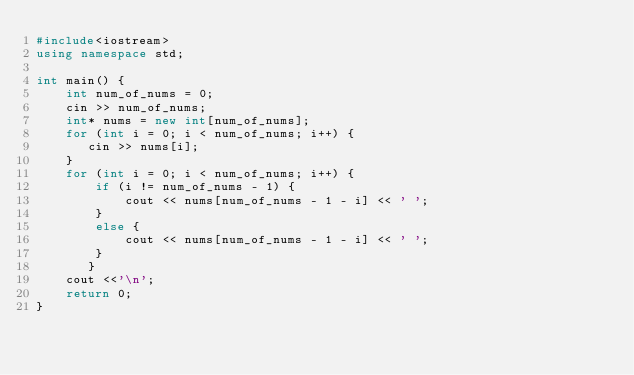Convert code to text. <code><loc_0><loc_0><loc_500><loc_500><_C++_>#include<iostream>
using namespace std;

int main() {
	int num_of_nums = 0;
	cin >> num_of_nums;
    int* nums = new int[num_of_nums];
    for (int i = 0; i < num_of_nums; i++) {
 	   cin >> nums[i];
    }
    for (int i = 0; i < num_of_nums; i++) {
		if (i != num_of_nums - 1) {
			cout << nums[num_of_nums - 1 - i] << ' ';
		}
		else {
			cout << nums[num_of_nums - 1 - i] << ' ';
		}
	   }
	cout <<'\n';
    return 0;
}</code> 